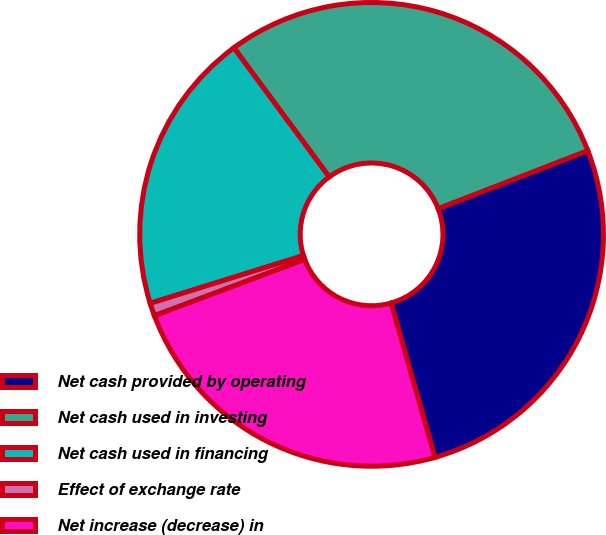<chart> <loc_0><loc_0><loc_500><loc_500><pie_chart><fcel>Net cash provided by operating<fcel>Net cash used in investing<fcel>Net cash used in financing<fcel>Effect of exchange rate<fcel>Net increase (decrease) in<nl><fcel>26.47%<fcel>29.24%<fcel>19.69%<fcel>0.9%<fcel>23.7%<nl></chart> 